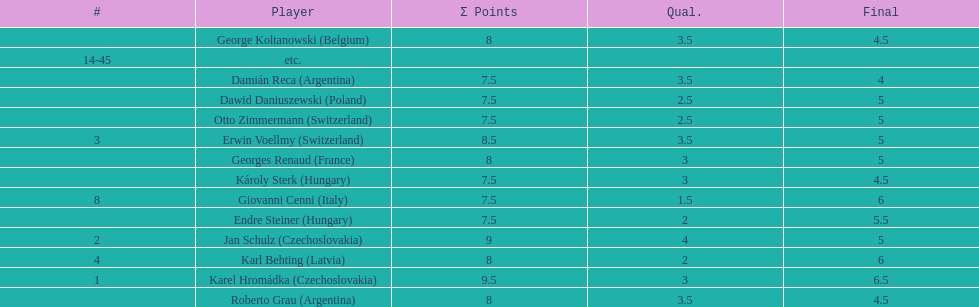What is the number of players who had a final score above 5? 4. 